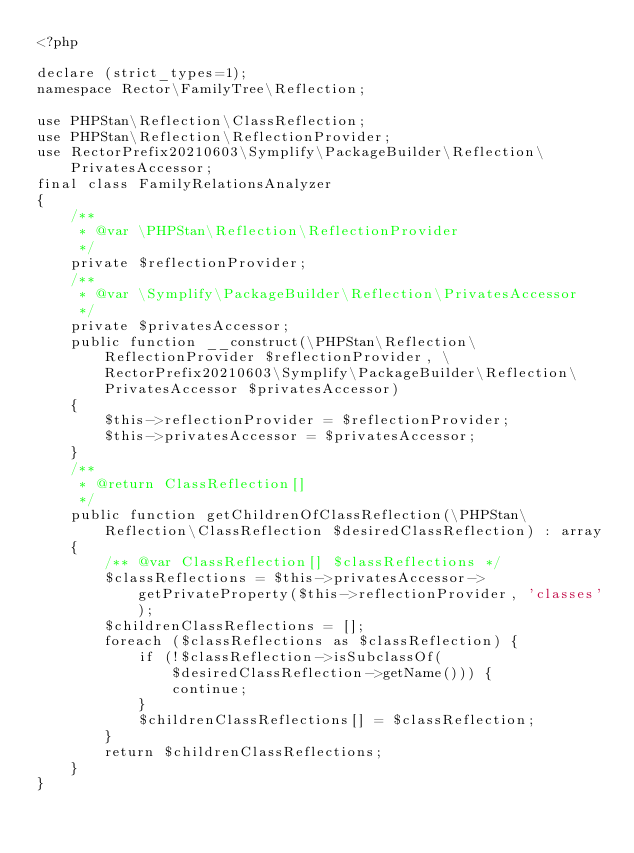Convert code to text. <code><loc_0><loc_0><loc_500><loc_500><_PHP_><?php

declare (strict_types=1);
namespace Rector\FamilyTree\Reflection;

use PHPStan\Reflection\ClassReflection;
use PHPStan\Reflection\ReflectionProvider;
use RectorPrefix20210603\Symplify\PackageBuilder\Reflection\PrivatesAccessor;
final class FamilyRelationsAnalyzer
{
    /**
     * @var \PHPStan\Reflection\ReflectionProvider
     */
    private $reflectionProvider;
    /**
     * @var \Symplify\PackageBuilder\Reflection\PrivatesAccessor
     */
    private $privatesAccessor;
    public function __construct(\PHPStan\Reflection\ReflectionProvider $reflectionProvider, \RectorPrefix20210603\Symplify\PackageBuilder\Reflection\PrivatesAccessor $privatesAccessor)
    {
        $this->reflectionProvider = $reflectionProvider;
        $this->privatesAccessor = $privatesAccessor;
    }
    /**
     * @return ClassReflection[]
     */
    public function getChildrenOfClassReflection(\PHPStan\Reflection\ClassReflection $desiredClassReflection) : array
    {
        /** @var ClassReflection[] $classReflections */
        $classReflections = $this->privatesAccessor->getPrivateProperty($this->reflectionProvider, 'classes');
        $childrenClassReflections = [];
        foreach ($classReflections as $classReflection) {
            if (!$classReflection->isSubclassOf($desiredClassReflection->getName())) {
                continue;
            }
            $childrenClassReflections[] = $classReflection;
        }
        return $childrenClassReflections;
    }
}
</code> 